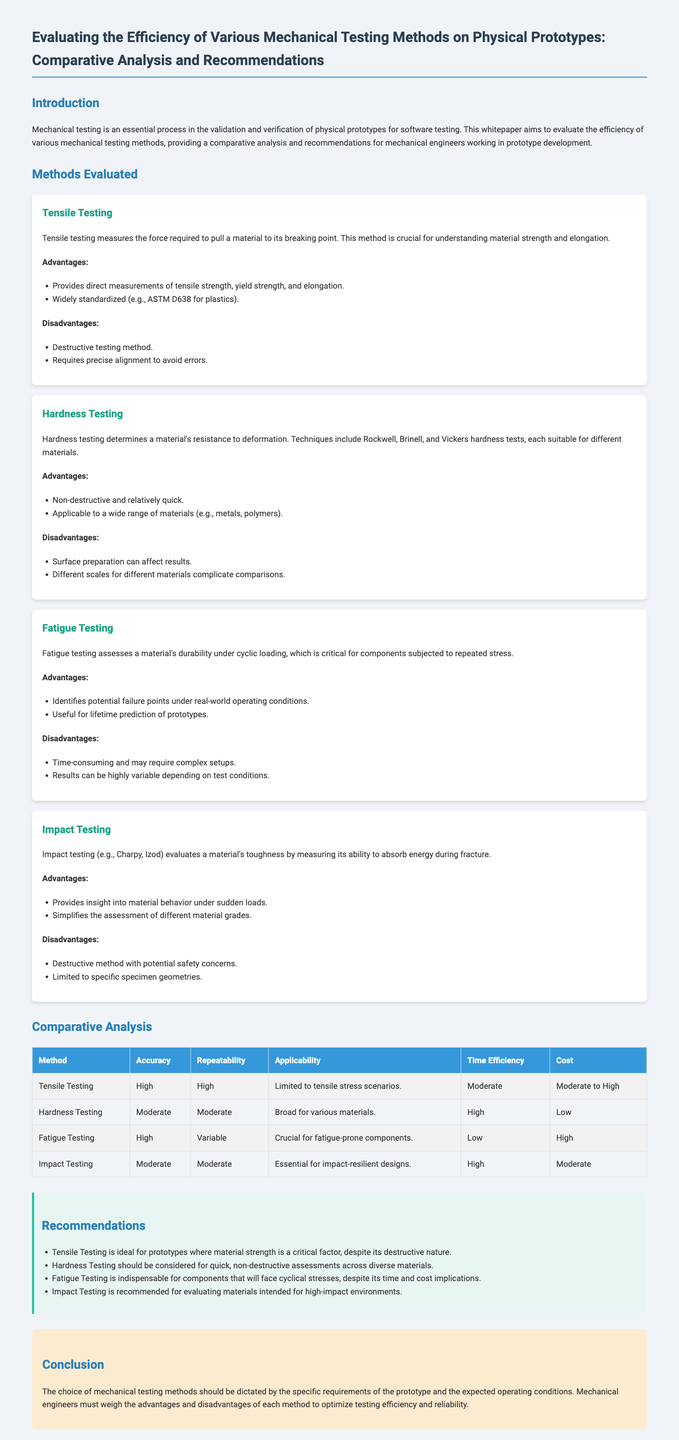what is the main focus of the whitepaper? The main focus of the whitepaper is to evaluate the efficiency of various mechanical testing methods for physical prototypes.
Answer: efficiency of various mechanical testing methods how many mechanical testing methods are evaluated? The document evaluates four distinct mechanical testing methods.
Answer: four what is the key advantage of tensile testing? The key advantage of tensile testing is that it provides direct measurements of tensile strength, yield strength, and elongation.
Answer: direct measurements of tensile strength, yield strength, and elongation which testing method is described as non-destructive and relatively quick? The method described as non-destructive and relatively quick is Hardness Testing.
Answer: Hardness Testing what is the time efficiency ranking for fatigue testing? The time efficiency ranking for fatigue testing is low.
Answer: low which method is recommended for components that will face cyclical stresses? The recommended method for components that will face cyclical stresses is Fatigue Testing.
Answer: Fatigue Testing what are the results for impact testing regarding accuracy? The results for impact testing regarding accuracy are moderate.
Answer: moderate what does the conclusion discuss about the choice of mechanical testing methods? The conclusion discusses that the choice should be dictated by specific requirements and expected operating conditions.
Answer: specific requirements and expected operating conditions what is one major disadvantage of tensile testing? One major disadvantage of tensile testing is that it is a destructive testing method.
Answer: destructive testing method 